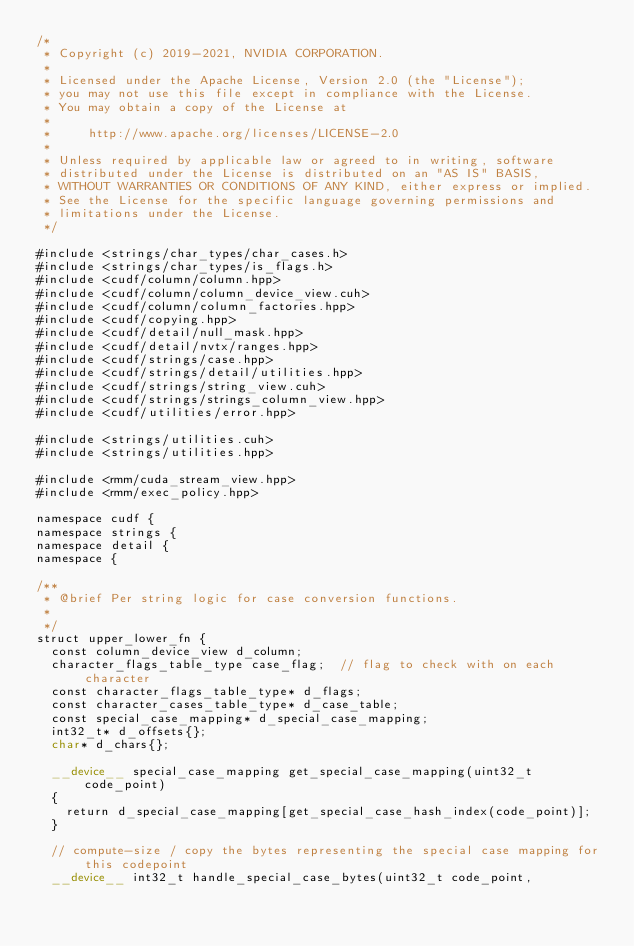<code> <loc_0><loc_0><loc_500><loc_500><_Cuda_>/*
 * Copyright (c) 2019-2021, NVIDIA CORPORATION.
 *
 * Licensed under the Apache License, Version 2.0 (the "License");
 * you may not use this file except in compliance with the License.
 * You may obtain a copy of the License at
 *
 *     http://www.apache.org/licenses/LICENSE-2.0
 *
 * Unless required by applicable law or agreed to in writing, software
 * distributed under the License is distributed on an "AS IS" BASIS,
 * WITHOUT WARRANTIES OR CONDITIONS OF ANY KIND, either express or implied.
 * See the License for the specific language governing permissions and
 * limitations under the License.
 */

#include <strings/char_types/char_cases.h>
#include <strings/char_types/is_flags.h>
#include <cudf/column/column.hpp>
#include <cudf/column/column_device_view.cuh>
#include <cudf/column/column_factories.hpp>
#include <cudf/copying.hpp>
#include <cudf/detail/null_mask.hpp>
#include <cudf/detail/nvtx/ranges.hpp>
#include <cudf/strings/case.hpp>
#include <cudf/strings/detail/utilities.hpp>
#include <cudf/strings/string_view.cuh>
#include <cudf/strings/strings_column_view.hpp>
#include <cudf/utilities/error.hpp>

#include <strings/utilities.cuh>
#include <strings/utilities.hpp>

#include <rmm/cuda_stream_view.hpp>
#include <rmm/exec_policy.hpp>

namespace cudf {
namespace strings {
namespace detail {
namespace {

/**
 * @brief Per string logic for case conversion functions.
 *
 */
struct upper_lower_fn {
  const column_device_view d_column;
  character_flags_table_type case_flag;  // flag to check with on each character
  const character_flags_table_type* d_flags;
  const character_cases_table_type* d_case_table;
  const special_case_mapping* d_special_case_mapping;
  int32_t* d_offsets{};
  char* d_chars{};

  __device__ special_case_mapping get_special_case_mapping(uint32_t code_point)
  {
    return d_special_case_mapping[get_special_case_hash_index(code_point)];
  }

  // compute-size / copy the bytes representing the special case mapping for this codepoint
  __device__ int32_t handle_special_case_bytes(uint32_t code_point,</code> 